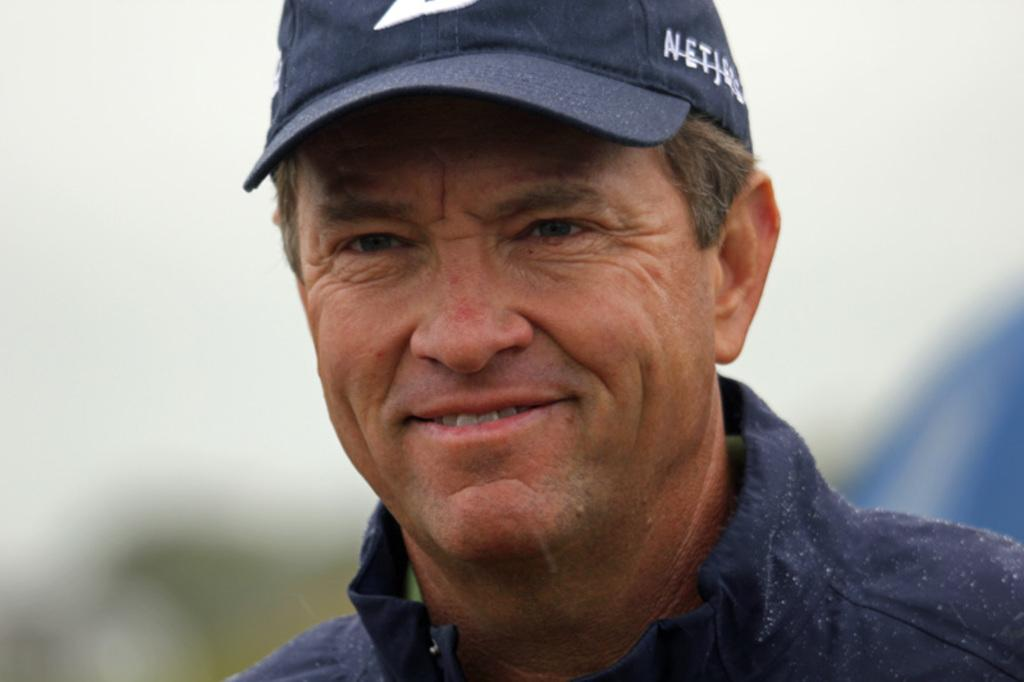Who or what is the main subject in the image? There is a person in the image. What is the person wearing? The person is wearing a blue dress and a cap. Can you describe the background of the image? The background of the image is blurred. What type of vest can be seen on the person in the image? There is no vest visible on the person in the image; they are wearing a blue dress and a cap. 